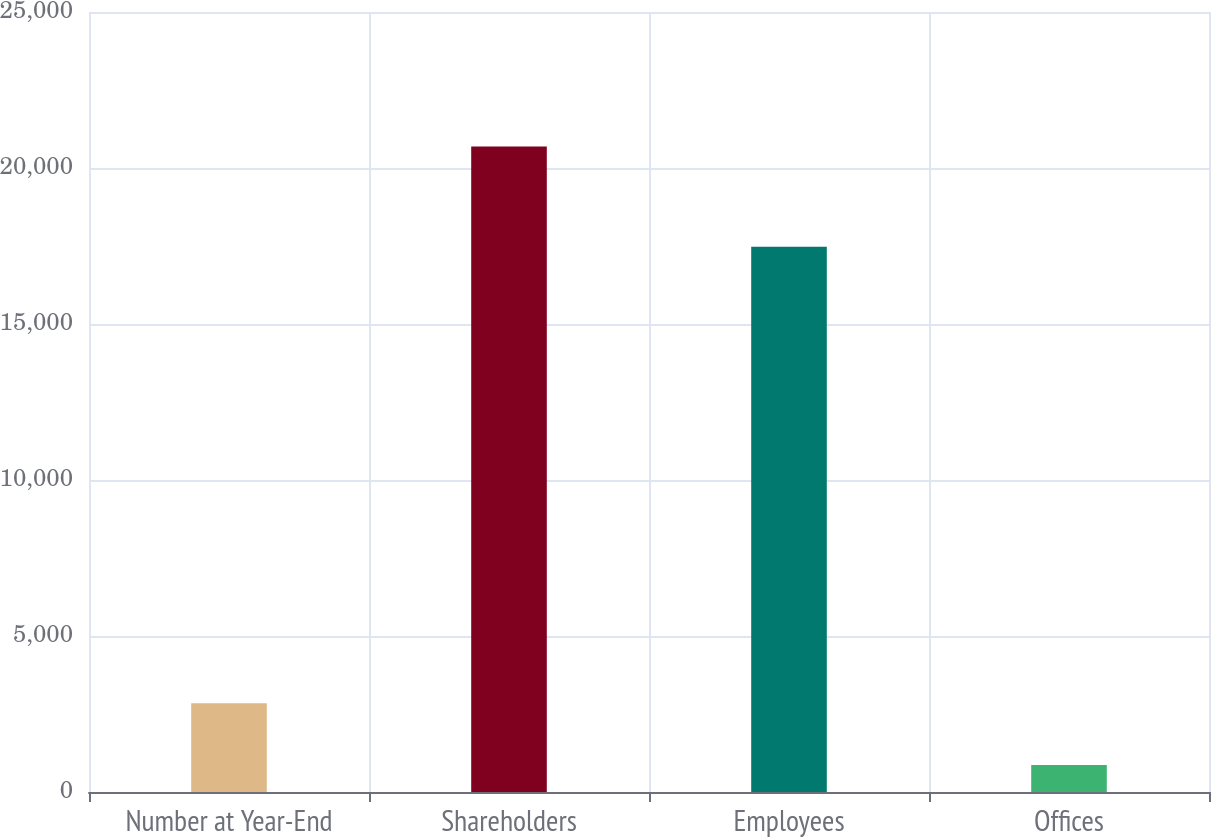Convert chart to OTSL. <chart><loc_0><loc_0><loc_500><loc_500><bar_chart><fcel>Number at Year-End<fcel>Shareholders<fcel>Employees<fcel>Offices<nl><fcel>2846<fcel>20693<fcel>17476<fcel>863<nl></chart> 